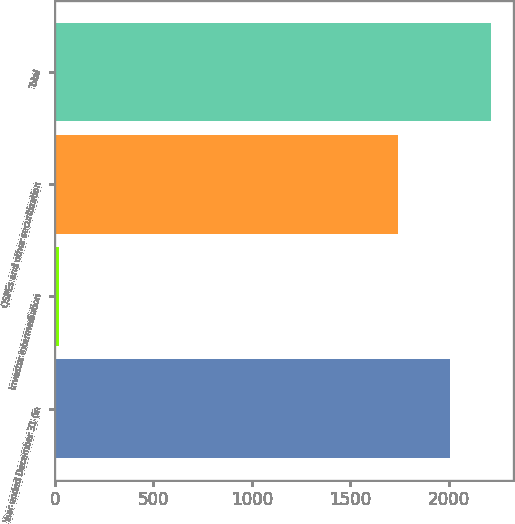Convert chart to OTSL. <chart><loc_0><loc_0><loc_500><loc_500><bar_chart><fcel>Year ended December 31 (in<fcel>Investor intermediation<fcel>QSPEs and other securitization<fcel>Total<nl><fcel>2008<fcel>22<fcel>1742<fcel>2213.6<nl></chart> 